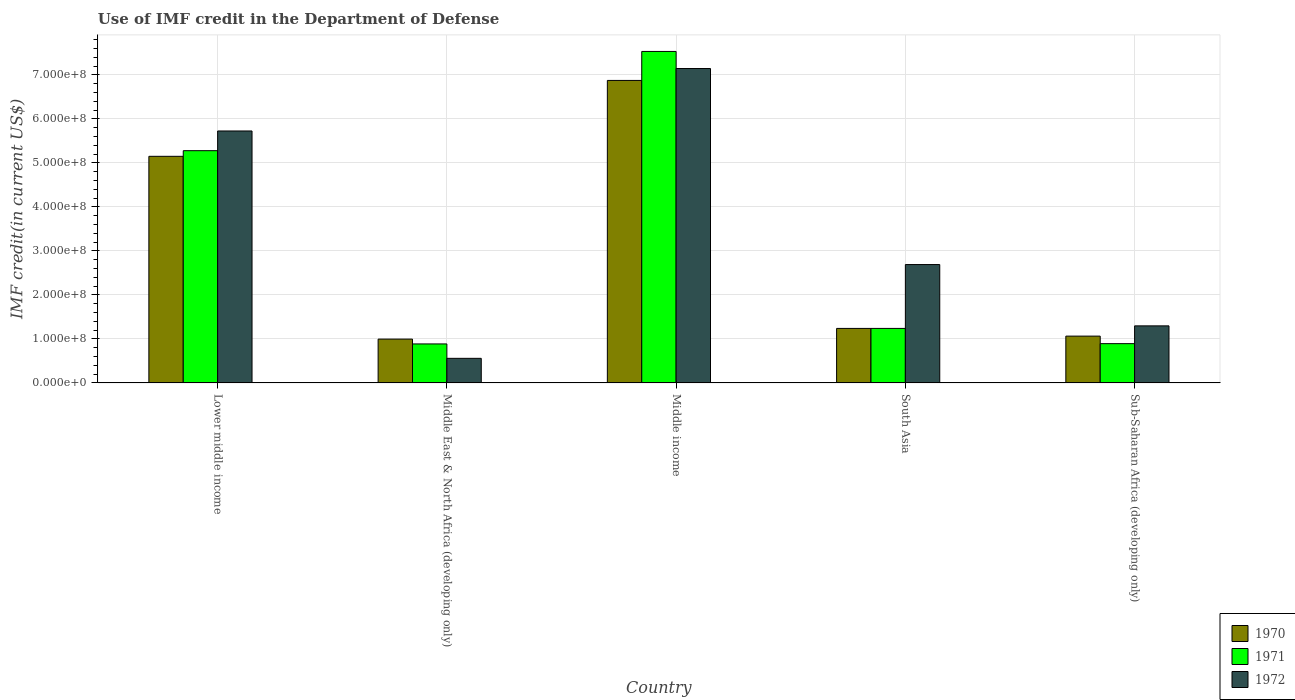Are the number of bars per tick equal to the number of legend labels?
Provide a short and direct response. Yes. Are the number of bars on each tick of the X-axis equal?
Provide a short and direct response. Yes. How many bars are there on the 5th tick from the left?
Give a very brief answer. 3. How many bars are there on the 2nd tick from the right?
Provide a succinct answer. 3. What is the label of the 4th group of bars from the left?
Offer a very short reply. South Asia. What is the IMF credit in the Department of Defense in 1972 in Middle East & North Africa (developing only)?
Offer a terse response. 5.59e+07. Across all countries, what is the maximum IMF credit in the Department of Defense in 1972?
Make the answer very short. 7.14e+08. Across all countries, what is the minimum IMF credit in the Department of Defense in 1970?
Provide a short and direct response. 9.96e+07. In which country was the IMF credit in the Department of Defense in 1971 minimum?
Your answer should be compact. Middle East & North Africa (developing only). What is the total IMF credit in the Department of Defense in 1971 in the graph?
Your response must be concise. 1.58e+09. What is the difference between the IMF credit in the Department of Defense in 1970 in Middle East & North Africa (developing only) and that in Sub-Saharan Africa (developing only)?
Your answer should be very brief. -6.78e+06. What is the difference between the IMF credit in the Department of Defense in 1971 in Middle East & North Africa (developing only) and the IMF credit in the Department of Defense in 1970 in Lower middle income?
Your answer should be very brief. -4.26e+08. What is the average IMF credit in the Department of Defense in 1971 per country?
Give a very brief answer. 3.17e+08. What is the difference between the IMF credit in the Department of Defense of/in 1971 and IMF credit in the Department of Defense of/in 1970 in South Asia?
Your answer should be very brief. 0. In how many countries, is the IMF credit in the Department of Defense in 1971 greater than 320000000 US$?
Provide a succinct answer. 2. What is the ratio of the IMF credit in the Department of Defense in 1972 in Middle East & North Africa (developing only) to that in Sub-Saharan Africa (developing only)?
Give a very brief answer. 0.43. Is the IMF credit in the Department of Defense in 1972 in Middle East & North Africa (developing only) less than that in South Asia?
Provide a short and direct response. Yes. Is the difference between the IMF credit in the Department of Defense in 1971 in Middle East & North Africa (developing only) and Sub-Saharan Africa (developing only) greater than the difference between the IMF credit in the Department of Defense in 1970 in Middle East & North Africa (developing only) and Sub-Saharan Africa (developing only)?
Give a very brief answer. Yes. What is the difference between the highest and the second highest IMF credit in the Department of Defense in 1972?
Your answer should be compact. -4.45e+08. What is the difference between the highest and the lowest IMF credit in the Department of Defense in 1970?
Offer a very short reply. 5.88e+08. In how many countries, is the IMF credit in the Department of Defense in 1972 greater than the average IMF credit in the Department of Defense in 1972 taken over all countries?
Your answer should be compact. 2. Is the sum of the IMF credit in the Department of Defense in 1972 in South Asia and Sub-Saharan Africa (developing only) greater than the maximum IMF credit in the Department of Defense in 1971 across all countries?
Your response must be concise. No. What does the 2nd bar from the right in Middle income represents?
Ensure brevity in your answer.  1971. How many bars are there?
Offer a very short reply. 15. Are all the bars in the graph horizontal?
Ensure brevity in your answer.  No. How many countries are there in the graph?
Your response must be concise. 5. Does the graph contain any zero values?
Make the answer very short. No. Does the graph contain grids?
Keep it short and to the point. Yes. Where does the legend appear in the graph?
Provide a succinct answer. Bottom right. How many legend labels are there?
Offer a terse response. 3. How are the legend labels stacked?
Ensure brevity in your answer.  Vertical. What is the title of the graph?
Your response must be concise. Use of IMF credit in the Department of Defense. What is the label or title of the X-axis?
Provide a short and direct response. Country. What is the label or title of the Y-axis?
Give a very brief answer. IMF credit(in current US$). What is the IMF credit(in current US$) in 1970 in Lower middle income?
Provide a succinct answer. 5.15e+08. What is the IMF credit(in current US$) in 1971 in Lower middle income?
Offer a terse response. 5.28e+08. What is the IMF credit(in current US$) in 1972 in Lower middle income?
Your answer should be very brief. 5.73e+08. What is the IMF credit(in current US$) in 1970 in Middle East & North Africa (developing only)?
Keep it short and to the point. 9.96e+07. What is the IMF credit(in current US$) in 1971 in Middle East & North Africa (developing only)?
Your answer should be very brief. 8.86e+07. What is the IMF credit(in current US$) of 1972 in Middle East & North Africa (developing only)?
Offer a very short reply. 5.59e+07. What is the IMF credit(in current US$) in 1970 in Middle income?
Offer a very short reply. 6.87e+08. What is the IMF credit(in current US$) of 1971 in Middle income?
Give a very brief answer. 7.53e+08. What is the IMF credit(in current US$) of 1972 in Middle income?
Ensure brevity in your answer.  7.14e+08. What is the IMF credit(in current US$) of 1970 in South Asia?
Offer a terse response. 1.24e+08. What is the IMF credit(in current US$) in 1971 in South Asia?
Your answer should be compact. 1.24e+08. What is the IMF credit(in current US$) of 1972 in South Asia?
Make the answer very short. 2.69e+08. What is the IMF credit(in current US$) in 1970 in Sub-Saharan Africa (developing only)?
Provide a short and direct response. 1.06e+08. What is the IMF credit(in current US$) in 1971 in Sub-Saharan Africa (developing only)?
Make the answer very short. 8.93e+07. What is the IMF credit(in current US$) of 1972 in Sub-Saharan Africa (developing only)?
Provide a succinct answer. 1.30e+08. Across all countries, what is the maximum IMF credit(in current US$) of 1970?
Provide a succinct answer. 6.87e+08. Across all countries, what is the maximum IMF credit(in current US$) of 1971?
Your answer should be very brief. 7.53e+08. Across all countries, what is the maximum IMF credit(in current US$) of 1972?
Your answer should be very brief. 7.14e+08. Across all countries, what is the minimum IMF credit(in current US$) of 1970?
Ensure brevity in your answer.  9.96e+07. Across all countries, what is the minimum IMF credit(in current US$) of 1971?
Keep it short and to the point. 8.86e+07. Across all countries, what is the minimum IMF credit(in current US$) of 1972?
Give a very brief answer. 5.59e+07. What is the total IMF credit(in current US$) in 1970 in the graph?
Provide a succinct answer. 1.53e+09. What is the total IMF credit(in current US$) of 1971 in the graph?
Ensure brevity in your answer.  1.58e+09. What is the total IMF credit(in current US$) of 1972 in the graph?
Your answer should be compact. 1.74e+09. What is the difference between the IMF credit(in current US$) in 1970 in Lower middle income and that in Middle East & North Africa (developing only)?
Make the answer very short. 4.15e+08. What is the difference between the IMF credit(in current US$) in 1971 in Lower middle income and that in Middle East & North Africa (developing only)?
Offer a terse response. 4.39e+08. What is the difference between the IMF credit(in current US$) in 1972 in Lower middle income and that in Middle East & North Africa (developing only)?
Ensure brevity in your answer.  5.17e+08. What is the difference between the IMF credit(in current US$) in 1970 in Lower middle income and that in Middle income?
Offer a terse response. -1.72e+08. What is the difference between the IMF credit(in current US$) of 1971 in Lower middle income and that in Middle income?
Offer a very short reply. -2.25e+08. What is the difference between the IMF credit(in current US$) of 1972 in Lower middle income and that in Middle income?
Provide a short and direct response. -1.42e+08. What is the difference between the IMF credit(in current US$) of 1970 in Lower middle income and that in South Asia?
Ensure brevity in your answer.  3.91e+08. What is the difference between the IMF credit(in current US$) of 1971 in Lower middle income and that in South Asia?
Your answer should be very brief. 4.04e+08. What is the difference between the IMF credit(in current US$) of 1972 in Lower middle income and that in South Asia?
Your answer should be compact. 3.04e+08. What is the difference between the IMF credit(in current US$) in 1970 in Lower middle income and that in Sub-Saharan Africa (developing only)?
Your answer should be compact. 4.09e+08. What is the difference between the IMF credit(in current US$) in 1971 in Lower middle income and that in Sub-Saharan Africa (developing only)?
Ensure brevity in your answer.  4.38e+08. What is the difference between the IMF credit(in current US$) in 1972 in Lower middle income and that in Sub-Saharan Africa (developing only)?
Provide a succinct answer. 4.43e+08. What is the difference between the IMF credit(in current US$) of 1970 in Middle East & North Africa (developing only) and that in Middle income?
Your response must be concise. -5.88e+08. What is the difference between the IMF credit(in current US$) of 1971 in Middle East & North Africa (developing only) and that in Middle income?
Make the answer very short. -6.65e+08. What is the difference between the IMF credit(in current US$) in 1972 in Middle East & North Africa (developing only) and that in Middle income?
Give a very brief answer. -6.59e+08. What is the difference between the IMF credit(in current US$) of 1970 in Middle East & North Africa (developing only) and that in South Asia?
Your answer should be very brief. -2.43e+07. What is the difference between the IMF credit(in current US$) in 1971 in Middle East & North Africa (developing only) and that in South Asia?
Make the answer very short. -3.53e+07. What is the difference between the IMF credit(in current US$) of 1972 in Middle East & North Africa (developing only) and that in South Asia?
Provide a short and direct response. -2.13e+08. What is the difference between the IMF credit(in current US$) of 1970 in Middle East & North Africa (developing only) and that in Sub-Saharan Africa (developing only)?
Ensure brevity in your answer.  -6.78e+06. What is the difference between the IMF credit(in current US$) of 1971 in Middle East & North Africa (developing only) and that in Sub-Saharan Africa (developing only)?
Your answer should be compact. -6.60e+05. What is the difference between the IMF credit(in current US$) of 1972 in Middle East & North Africa (developing only) and that in Sub-Saharan Africa (developing only)?
Your answer should be compact. -7.38e+07. What is the difference between the IMF credit(in current US$) of 1970 in Middle income and that in South Asia?
Keep it short and to the point. 5.64e+08. What is the difference between the IMF credit(in current US$) in 1971 in Middle income and that in South Asia?
Ensure brevity in your answer.  6.29e+08. What is the difference between the IMF credit(in current US$) of 1972 in Middle income and that in South Asia?
Make the answer very short. 4.45e+08. What is the difference between the IMF credit(in current US$) of 1970 in Middle income and that in Sub-Saharan Africa (developing only)?
Your answer should be very brief. 5.81e+08. What is the difference between the IMF credit(in current US$) in 1971 in Middle income and that in Sub-Saharan Africa (developing only)?
Ensure brevity in your answer.  6.64e+08. What is the difference between the IMF credit(in current US$) of 1972 in Middle income and that in Sub-Saharan Africa (developing only)?
Ensure brevity in your answer.  5.85e+08. What is the difference between the IMF credit(in current US$) in 1970 in South Asia and that in Sub-Saharan Africa (developing only)?
Your answer should be compact. 1.75e+07. What is the difference between the IMF credit(in current US$) in 1971 in South Asia and that in Sub-Saharan Africa (developing only)?
Your answer should be compact. 3.46e+07. What is the difference between the IMF credit(in current US$) of 1972 in South Asia and that in Sub-Saharan Africa (developing only)?
Offer a very short reply. 1.39e+08. What is the difference between the IMF credit(in current US$) of 1970 in Lower middle income and the IMF credit(in current US$) of 1971 in Middle East & North Africa (developing only)?
Offer a terse response. 4.26e+08. What is the difference between the IMF credit(in current US$) of 1970 in Lower middle income and the IMF credit(in current US$) of 1972 in Middle East & North Africa (developing only)?
Make the answer very short. 4.59e+08. What is the difference between the IMF credit(in current US$) of 1971 in Lower middle income and the IMF credit(in current US$) of 1972 in Middle East & North Africa (developing only)?
Offer a very short reply. 4.72e+08. What is the difference between the IMF credit(in current US$) of 1970 in Lower middle income and the IMF credit(in current US$) of 1971 in Middle income?
Keep it short and to the point. -2.38e+08. What is the difference between the IMF credit(in current US$) in 1970 in Lower middle income and the IMF credit(in current US$) in 1972 in Middle income?
Ensure brevity in your answer.  -2.00e+08. What is the difference between the IMF credit(in current US$) of 1971 in Lower middle income and the IMF credit(in current US$) of 1972 in Middle income?
Provide a succinct answer. -1.87e+08. What is the difference between the IMF credit(in current US$) in 1970 in Lower middle income and the IMF credit(in current US$) in 1971 in South Asia?
Provide a short and direct response. 3.91e+08. What is the difference between the IMF credit(in current US$) of 1970 in Lower middle income and the IMF credit(in current US$) of 1972 in South Asia?
Offer a very short reply. 2.46e+08. What is the difference between the IMF credit(in current US$) in 1971 in Lower middle income and the IMF credit(in current US$) in 1972 in South Asia?
Make the answer very short. 2.59e+08. What is the difference between the IMF credit(in current US$) in 1970 in Lower middle income and the IMF credit(in current US$) in 1971 in Sub-Saharan Africa (developing only)?
Give a very brief answer. 4.26e+08. What is the difference between the IMF credit(in current US$) in 1970 in Lower middle income and the IMF credit(in current US$) in 1972 in Sub-Saharan Africa (developing only)?
Offer a terse response. 3.85e+08. What is the difference between the IMF credit(in current US$) in 1971 in Lower middle income and the IMF credit(in current US$) in 1972 in Sub-Saharan Africa (developing only)?
Offer a very short reply. 3.98e+08. What is the difference between the IMF credit(in current US$) of 1970 in Middle East & North Africa (developing only) and the IMF credit(in current US$) of 1971 in Middle income?
Offer a terse response. -6.54e+08. What is the difference between the IMF credit(in current US$) in 1970 in Middle East & North Africa (developing only) and the IMF credit(in current US$) in 1972 in Middle income?
Give a very brief answer. -6.15e+08. What is the difference between the IMF credit(in current US$) of 1971 in Middle East & North Africa (developing only) and the IMF credit(in current US$) of 1972 in Middle income?
Provide a succinct answer. -6.26e+08. What is the difference between the IMF credit(in current US$) in 1970 in Middle East & North Africa (developing only) and the IMF credit(in current US$) in 1971 in South Asia?
Your response must be concise. -2.43e+07. What is the difference between the IMF credit(in current US$) of 1970 in Middle East & North Africa (developing only) and the IMF credit(in current US$) of 1972 in South Asia?
Give a very brief answer. -1.69e+08. What is the difference between the IMF credit(in current US$) of 1971 in Middle East & North Africa (developing only) and the IMF credit(in current US$) of 1972 in South Asia?
Make the answer very short. -1.80e+08. What is the difference between the IMF credit(in current US$) of 1970 in Middle East & North Africa (developing only) and the IMF credit(in current US$) of 1971 in Sub-Saharan Africa (developing only)?
Provide a short and direct response. 1.03e+07. What is the difference between the IMF credit(in current US$) of 1970 in Middle East & North Africa (developing only) and the IMF credit(in current US$) of 1972 in Sub-Saharan Africa (developing only)?
Your answer should be compact. -3.01e+07. What is the difference between the IMF credit(in current US$) of 1971 in Middle East & North Africa (developing only) and the IMF credit(in current US$) of 1972 in Sub-Saharan Africa (developing only)?
Your response must be concise. -4.11e+07. What is the difference between the IMF credit(in current US$) in 1970 in Middle income and the IMF credit(in current US$) in 1971 in South Asia?
Your response must be concise. 5.64e+08. What is the difference between the IMF credit(in current US$) in 1970 in Middle income and the IMF credit(in current US$) in 1972 in South Asia?
Provide a short and direct response. 4.18e+08. What is the difference between the IMF credit(in current US$) in 1971 in Middle income and the IMF credit(in current US$) in 1972 in South Asia?
Offer a terse response. 4.84e+08. What is the difference between the IMF credit(in current US$) of 1970 in Middle income and the IMF credit(in current US$) of 1971 in Sub-Saharan Africa (developing only)?
Make the answer very short. 5.98e+08. What is the difference between the IMF credit(in current US$) in 1970 in Middle income and the IMF credit(in current US$) in 1972 in Sub-Saharan Africa (developing only)?
Your answer should be very brief. 5.58e+08. What is the difference between the IMF credit(in current US$) in 1971 in Middle income and the IMF credit(in current US$) in 1972 in Sub-Saharan Africa (developing only)?
Your answer should be compact. 6.24e+08. What is the difference between the IMF credit(in current US$) in 1970 in South Asia and the IMF credit(in current US$) in 1971 in Sub-Saharan Africa (developing only)?
Your answer should be very brief. 3.46e+07. What is the difference between the IMF credit(in current US$) in 1970 in South Asia and the IMF credit(in current US$) in 1972 in Sub-Saharan Africa (developing only)?
Offer a very short reply. -5.79e+06. What is the difference between the IMF credit(in current US$) of 1971 in South Asia and the IMF credit(in current US$) of 1972 in Sub-Saharan Africa (developing only)?
Your answer should be compact. -5.79e+06. What is the average IMF credit(in current US$) in 1970 per country?
Your response must be concise. 3.06e+08. What is the average IMF credit(in current US$) in 1971 per country?
Give a very brief answer. 3.17e+08. What is the average IMF credit(in current US$) of 1972 per country?
Make the answer very short. 3.48e+08. What is the difference between the IMF credit(in current US$) of 1970 and IMF credit(in current US$) of 1971 in Lower middle income?
Your response must be concise. -1.28e+07. What is the difference between the IMF credit(in current US$) of 1970 and IMF credit(in current US$) of 1972 in Lower middle income?
Ensure brevity in your answer.  -5.76e+07. What is the difference between the IMF credit(in current US$) of 1971 and IMF credit(in current US$) of 1972 in Lower middle income?
Keep it short and to the point. -4.48e+07. What is the difference between the IMF credit(in current US$) in 1970 and IMF credit(in current US$) in 1971 in Middle East & North Africa (developing only)?
Provide a short and direct response. 1.10e+07. What is the difference between the IMF credit(in current US$) of 1970 and IMF credit(in current US$) of 1972 in Middle East & North Africa (developing only)?
Provide a short and direct response. 4.37e+07. What is the difference between the IMF credit(in current US$) in 1971 and IMF credit(in current US$) in 1972 in Middle East & North Africa (developing only)?
Your answer should be very brief. 3.27e+07. What is the difference between the IMF credit(in current US$) in 1970 and IMF credit(in current US$) in 1971 in Middle income?
Give a very brief answer. -6.58e+07. What is the difference between the IMF credit(in current US$) of 1970 and IMF credit(in current US$) of 1972 in Middle income?
Your answer should be compact. -2.71e+07. What is the difference between the IMF credit(in current US$) of 1971 and IMF credit(in current US$) of 1972 in Middle income?
Make the answer very short. 3.88e+07. What is the difference between the IMF credit(in current US$) in 1970 and IMF credit(in current US$) in 1971 in South Asia?
Make the answer very short. 0. What is the difference between the IMF credit(in current US$) in 1970 and IMF credit(in current US$) in 1972 in South Asia?
Offer a very short reply. -1.45e+08. What is the difference between the IMF credit(in current US$) in 1971 and IMF credit(in current US$) in 1972 in South Asia?
Offer a very short reply. -1.45e+08. What is the difference between the IMF credit(in current US$) of 1970 and IMF credit(in current US$) of 1971 in Sub-Saharan Africa (developing only)?
Offer a terse response. 1.71e+07. What is the difference between the IMF credit(in current US$) of 1970 and IMF credit(in current US$) of 1972 in Sub-Saharan Africa (developing only)?
Provide a succinct answer. -2.33e+07. What is the difference between the IMF credit(in current US$) in 1971 and IMF credit(in current US$) in 1972 in Sub-Saharan Africa (developing only)?
Your answer should be compact. -4.04e+07. What is the ratio of the IMF credit(in current US$) in 1970 in Lower middle income to that in Middle East & North Africa (developing only)?
Offer a terse response. 5.17. What is the ratio of the IMF credit(in current US$) of 1971 in Lower middle income to that in Middle East & North Africa (developing only)?
Offer a very short reply. 5.95. What is the ratio of the IMF credit(in current US$) of 1972 in Lower middle income to that in Middle East & North Africa (developing only)?
Your response must be concise. 10.24. What is the ratio of the IMF credit(in current US$) of 1970 in Lower middle income to that in Middle income?
Your response must be concise. 0.75. What is the ratio of the IMF credit(in current US$) in 1971 in Lower middle income to that in Middle income?
Ensure brevity in your answer.  0.7. What is the ratio of the IMF credit(in current US$) in 1972 in Lower middle income to that in Middle income?
Give a very brief answer. 0.8. What is the ratio of the IMF credit(in current US$) in 1970 in Lower middle income to that in South Asia?
Provide a succinct answer. 4.16. What is the ratio of the IMF credit(in current US$) of 1971 in Lower middle income to that in South Asia?
Ensure brevity in your answer.  4.26. What is the ratio of the IMF credit(in current US$) in 1972 in Lower middle income to that in South Asia?
Your answer should be very brief. 2.13. What is the ratio of the IMF credit(in current US$) of 1970 in Lower middle income to that in Sub-Saharan Africa (developing only)?
Your answer should be compact. 4.84. What is the ratio of the IMF credit(in current US$) of 1971 in Lower middle income to that in Sub-Saharan Africa (developing only)?
Keep it short and to the point. 5.91. What is the ratio of the IMF credit(in current US$) of 1972 in Lower middle income to that in Sub-Saharan Africa (developing only)?
Your answer should be compact. 4.41. What is the ratio of the IMF credit(in current US$) of 1970 in Middle East & North Africa (developing only) to that in Middle income?
Provide a short and direct response. 0.14. What is the ratio of the IMF credit(in current US$) of 1971 in Middle East & North Africa (developing only) to that in Middle income?
Provide a short and direct response. 0.12. What is the ratio of the IMF credit(in current US$) of 1972 in Middle East & North Africa (developing only) to that in Middle income?
Give a very brief answer. 0.08. What is the ratio of the IMF credit(in current US$) of 1970 in Middle East & North Africa (developing only) to that in South Asia?
Your response must be concise. 0.8. What is the ratio of the IMF credit(in current US$) of 1971 in Middle East & North Africa (developing only) to that in South Asia?
Provide a succinct answer. 0.72. What is the ratio of the IMF credit(in current US$) of 1972 in Middle East & North Africa (developing only) to that in South Asia?
Keep it short and to the point. 0.21. What is the ratio of the IMF credit(in current US$) of 1970 in Middle East & North Africa (developing only) to that in Sub-Saharan Africa (developing only)?
Your answer should be compact. 0.94. What is the ratio of the IMF credit(in current US$) of 1971 in Middle East & North Africa (developing only) to that in Sub-Saharan Africa (developing only)?
Your response must be concise. 0.99. What is the ratio of the IMF credit(in current US$) of 1972 in Middle East & North Africa (developing only) to that in Sub-Saharan Africa (developing only)?
Make the answer very short. 0.43. What is the ratio of the IMF credit(in current US$) in 1970 in Middle income to that in South Asia?
Keep it short and to the point. 5.55. What is the ratio of the IMF credit(in current US$) in 1971 in Middle income to that in South Asia?
Offer a very short reply. 6.08. What is the ratio of the IMF credit(in current US$) in 1972 in Middle income to that in South Asia?
Make the answer very short. 2.66. What is the ratio of the IMF credit(in current US$) of 1970 in Middle income to that in Sub-Saharan Africa (developing only)?
Your response must be concise. 6.46. What is the ratio of the IMF credit(in current US$) in 1971 in Middle income to that in Sub-Saharan Africa (developing only)?
Offer a very short reply. 8.44. What is the ratio of the IMF credit(in current US$) of 1972 in Middle income to that in Sub-Saharan Africa (developing only)?
Keep it short and to the point. 5.51. What is the ratio of the IMF credit(in current US$) of 1970 in South Asia to that in Sub-Saharan Africa (developing only)?
Your answer should be very brief. 1.16. What is the ratio of the IMF credit(in current US$) in 1971 in South Asia to that in Sub-Saharan Africa (developing only)?
Give a very brief answer. 1.39. What is the ratio of the IMF credit(in current US$) in 1972 in South Asia to that in Sub-Saharan Africa (developing only)?
Provide a succinct answer. 2.07. What is the difference between the highest and the second highest IMF credit(in current US$) of 1970?
Make the answer very short. 1.72e+08. What is the difference between the highest and the second highest IMF credit(in current US$) in 1971?
Keep it short and to the point. 2.25e+08. What is the difference between the highest and the second highest IMF credit(in current US$) of 1972?
Provide a short and direct response. 1.42e+08. What is the difference between the highest and the lowest IMF credit(in current US$) in 1970?
Make the answer very short. 5.88e+08. What is the difference between the highest and the lowest IMF credit(in current US$) in 1971?
Give a very brief answer. 6.65e+08. What is the difference between the highest and the lowest IMF credit(in current US$) of 1972?
Provide a succinct answer. 6.59e+08. 